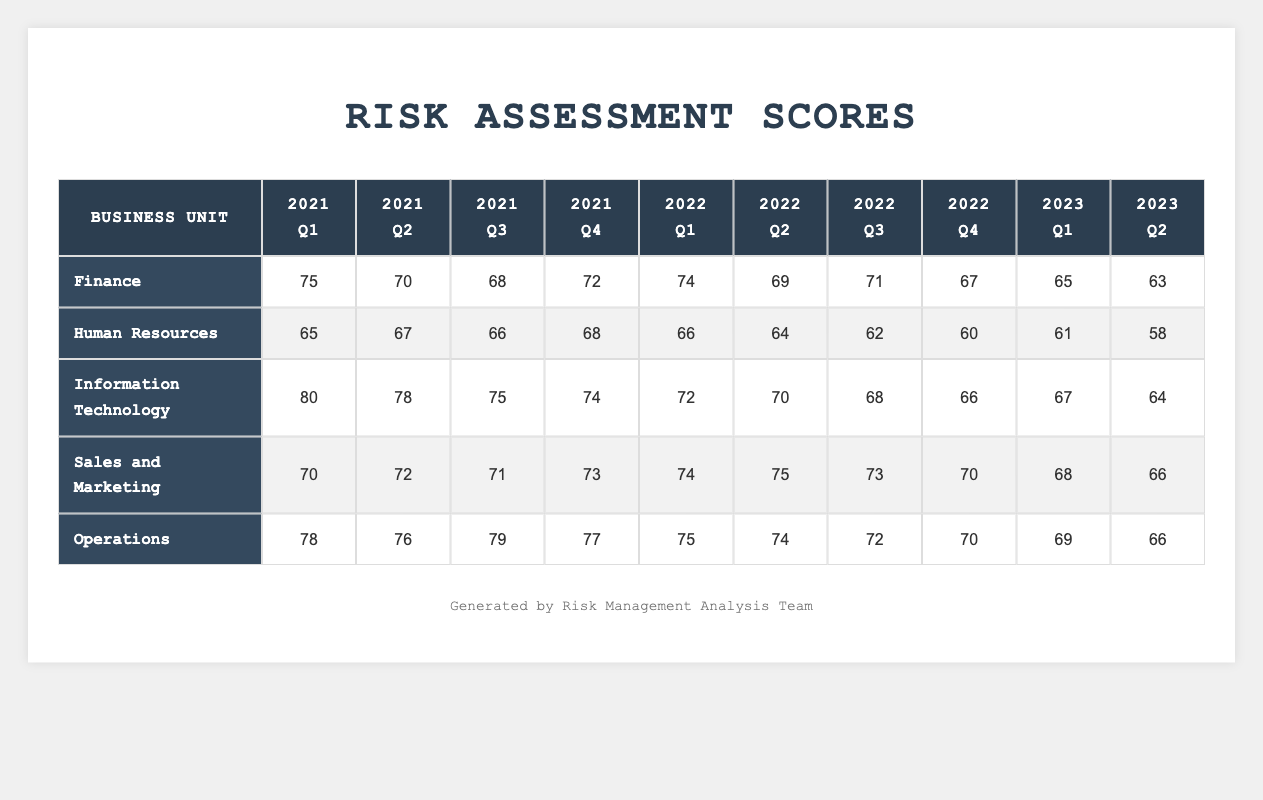What was the highest risk assessment score recorded for the Finance business unit? The highest score for Finance can be found in the 2021 Q1 column, which is 75. I found this by scanning the scores for Finance column by column.
Answer: 75 What score did the Human Resources business unit achieve in 2023 Q2? The score for Human Resources in 2023 Q2 is found directly in that column, which is 58.
Answer: 58 Which business unit had the lowest risk assessment score in 2022 Q4? To find the lowest score for 2022 Q4, I compared the scores: Finance (67), Human Resources (60), IT (66), Sales and Marketing (70), and Operations (70). The lowest is Human Resources at 60.
Answer: Human Resources What is the average risk assessment score for the Operations business unit over the recorded periods? The scores for Operations are (78 + 76 + 79 + 77 + 75 + 74 + 72 + 70 + 69 + 66) = 746. There are 10 scores, so the average is 746 / 10 = 74.6, which can be rounded to 75.
Answer: 75 Did the Information Technology unit's risk assessment score increase or decrease from 2021 Q1 to 2023 Q2? In 2021 Q1, IT had a score of 80 and decreased to 64 by 2023 Q2. Since 64 is lower than 80, IT's score decreased over this time period.
Answer: Decrease What was the total risk assessment score for Sales and Marketing from 2021 Q1 to 2023 Q2? The total score is calculated by adding the scores from each quarter: 70 + 72 + 71 + 73 + 74 + 75 + 73 + 70 + 68 + 66 =  742.
Answer: 742 Which business unit had the highest risk assessment score for 2021 Q4? The scores in 2021 Q4 are: Finance (72), HR (68), IT (74), Sales and Marketing (73), Operations (77). The highest score is for IT at 74.
Answer: Information Technology What was the trend for the Finance business unit from 2021 Q1 to 2023 Q2, and what is the final score? Looking through the quarterly scores: 75, 70, 68, 72, 74, 69, 71, 67, 65, 63, Finance's score fluctuated but generally decreased after 2021 Q1. The final score in 2023 Q2 is 63.
Answer: Decreased; final score is 63 Which quarter saw the highest overall risk assessment score across all business units? By scanning through all the scores for each quarter, we find the highest values: Q1 of 2021 has scores summing to: (75 + 65 + 80 + 70 + 78 = 368). Subsequent quarters are lower than this total, making Q1 2021 the highest overall.
Answer: 2021 Q1 In which quarter did the Human Resources business unit experience its greatest decline? To find the greatest decline, I compare differences between consecutive quarters: Q1 to Q2 (65 to 67 = increase), Q2 to Q3 (67 to 66 = decrease of 1), etc. The largest drop is from Q4 2022 (60) to Q1 2023 (61), a decline of 2. Thus, the greatest decline is between Q1 2022 and Q4 2022.
Answer: 2022 Q2 to 2022 Q3 